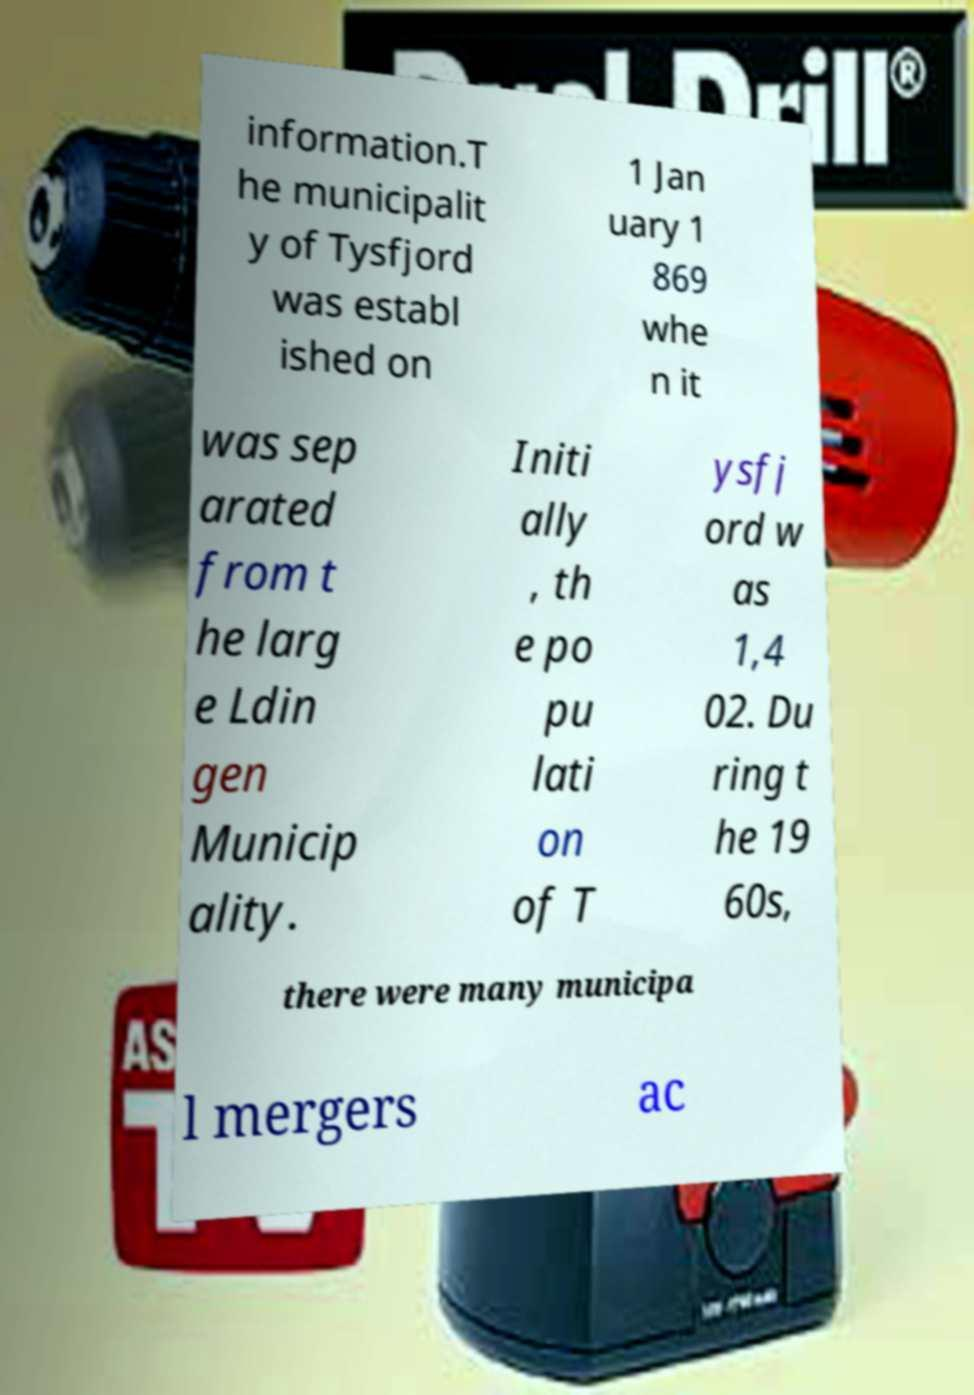There's text embedded in this image that I need extracted. Can you transcribe it verbatim? information.T he municipalit y of Tysfjord was establ ished on 1 Jan uary 1 869 whe n it was sep arated from t he larg e Ldin gen Municip ality. Initi ally , th e po pu lati on of T ysfj ord w as 1,4 02. Du ring t he 19 60s, there were many municipa l mergers ac 